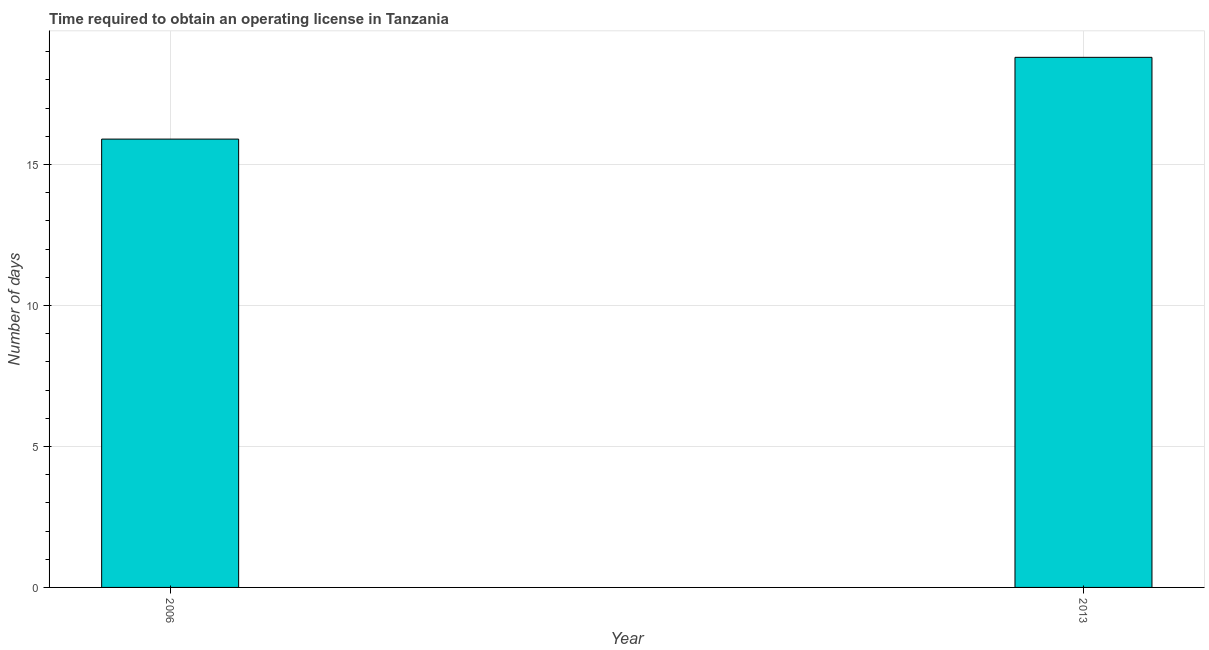Does the graph contain any zero values?
Ensure brevity in your answer.  No. Does the graph contain grids?
Keep it short and to the point. Yes. What is the title of the graph?
Provide a short and direct response. Time required to obtain an operating license in Tanzania. What is the label or title of the X-axis?
Provide a short and direct response. Year. What is the label or title of the Y-axis?
Provide a succinct answer. Number of days. Across all years, what is the maximum number of days to obtain operating license?
Offer a terse response. 18.8. In which year was the number of days to obtain operating license maximum?
Make the answer very short. 2013. What is the sum of the number of days to obtain operating license?
Provide a succinct answer. 34.7. What is the difference between the number of days to obtain operating license in 2006 and 2013?
Give a very brief answer. -2.9. What is the average number of days to obtain operating license per year?
Provide a succinct answer. 17.35. What is the median number of days to obtain operating license?
Ensure brevity in your answer.  17.35. In how many years, is the number of days to obtain operating license greater than 17 days?
Provide a succinct answer. 1. What is the ratio of the number of days to obtain operating license in 2006 to that in 2013?
Provide a succinct answer. 0.85. Is the number of days to obtain operating license in 2006 less than that in 2013?
Your answer should be compact. Yes. In how many years, is the number of days to obtain operating license greater than the average number of days to obtain operating license taken over all years?
Ensure brevity in your answer.  1. Are all the bars in the graph horizontal?
Offer a terse response. No. What is the difference between two consecutive major ticks on the Y-axis?
Give a very brief answer. 5. What is the ratio of the Number of days in 2006 to that in 2013?
Offer a very short reply. 0.85. 